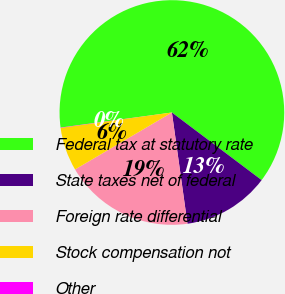<chart> <loc_0><loc_0><loc_500><loc_500><pie_chart><fcel>Federal tax at statutory rate<fcel>State taxes net of federal<fcel>Foreign rate differential<fcel>Stock compensation not<fcel>Other<nl><fcel>62.42%<fcel>12.51%<fcel>18.75%<fcel>6.28%<fcel>0.04%<nl></chart> 